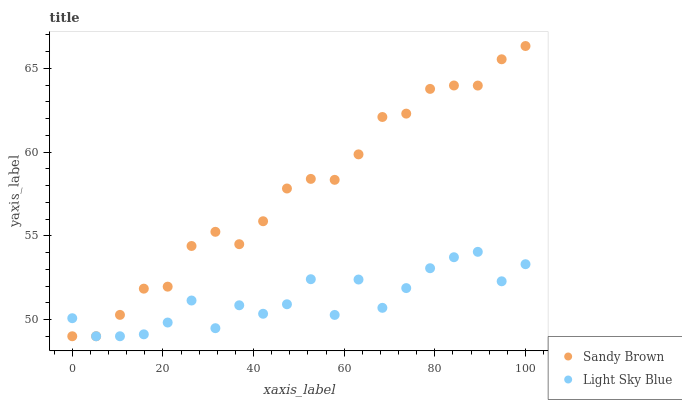Does Light Sky Blue have the minimum area under the curve?
Answer yes or no. Yes. Does Sandy Brown have the maximum area under the curve?
Answer yes or no. Yes. Does Sandy Brown have the minimum area under the curve?
Answer yes or no. No. Is Sandy Brown the smoothest?
Answer yes or no. Yes. Is Light Sky Blue the roughest?
Answer yes or no. Yes. Is Sandy Brown the roughest?
Answer yes or no. No. Does Light Sky Blue have the lowest value?
Answer yes or no. Yes. Does Sandy Brown have the highest value?
Answer yes or no. Yes. Does Light Sky Blue intersect Sandy Brown?
Answer yes or no. Yes. Is Light Sky Blue less than Sandy Brown?
Answer yes or no. No. Is Light Sky Blue greater than Sandy Brown?
Answer yes or no. No. 